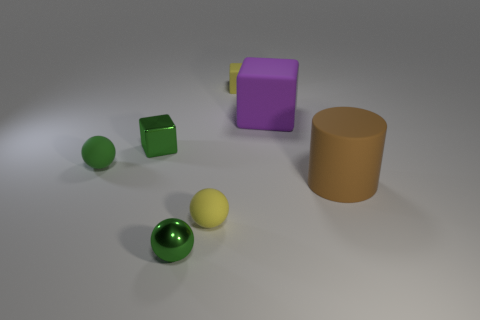Is there any other thing that is the same shape as the brown matte object?
Your answer should be very brief. No. What shape is the green thing left of the small block that is on the left side of the green object in front of the small yellow ball?
Provide a short and direct response. Sphere. The green metallic ball has what size?
Keep it short and to the point. Small. There is a object that is the same material as the green block; what color is it?
Your answer should be compact. Green. How many cubes are made of the same material as the large cylinder?
Ensure brevity in your answer.  2. Does the shiny ball have the same color as the block that is on the left side of the tiny matte block?
Provide a short and direct response. Yes. There is a small metal object that is right of the small metallic thing that is behind the yellow rubber ball; what color is it?
Provide a succinct answer. Green. There is a rubber cube that is the same size as the yellow rubber ball; what is its color?
Your response must be concise. Yellow. Are there any small green things that have the same shape as the purple matte object?
Provide a short and direct response. Yes. What is the shape of the tiny green rubber thing?
Your response must be concise. Sphere. 